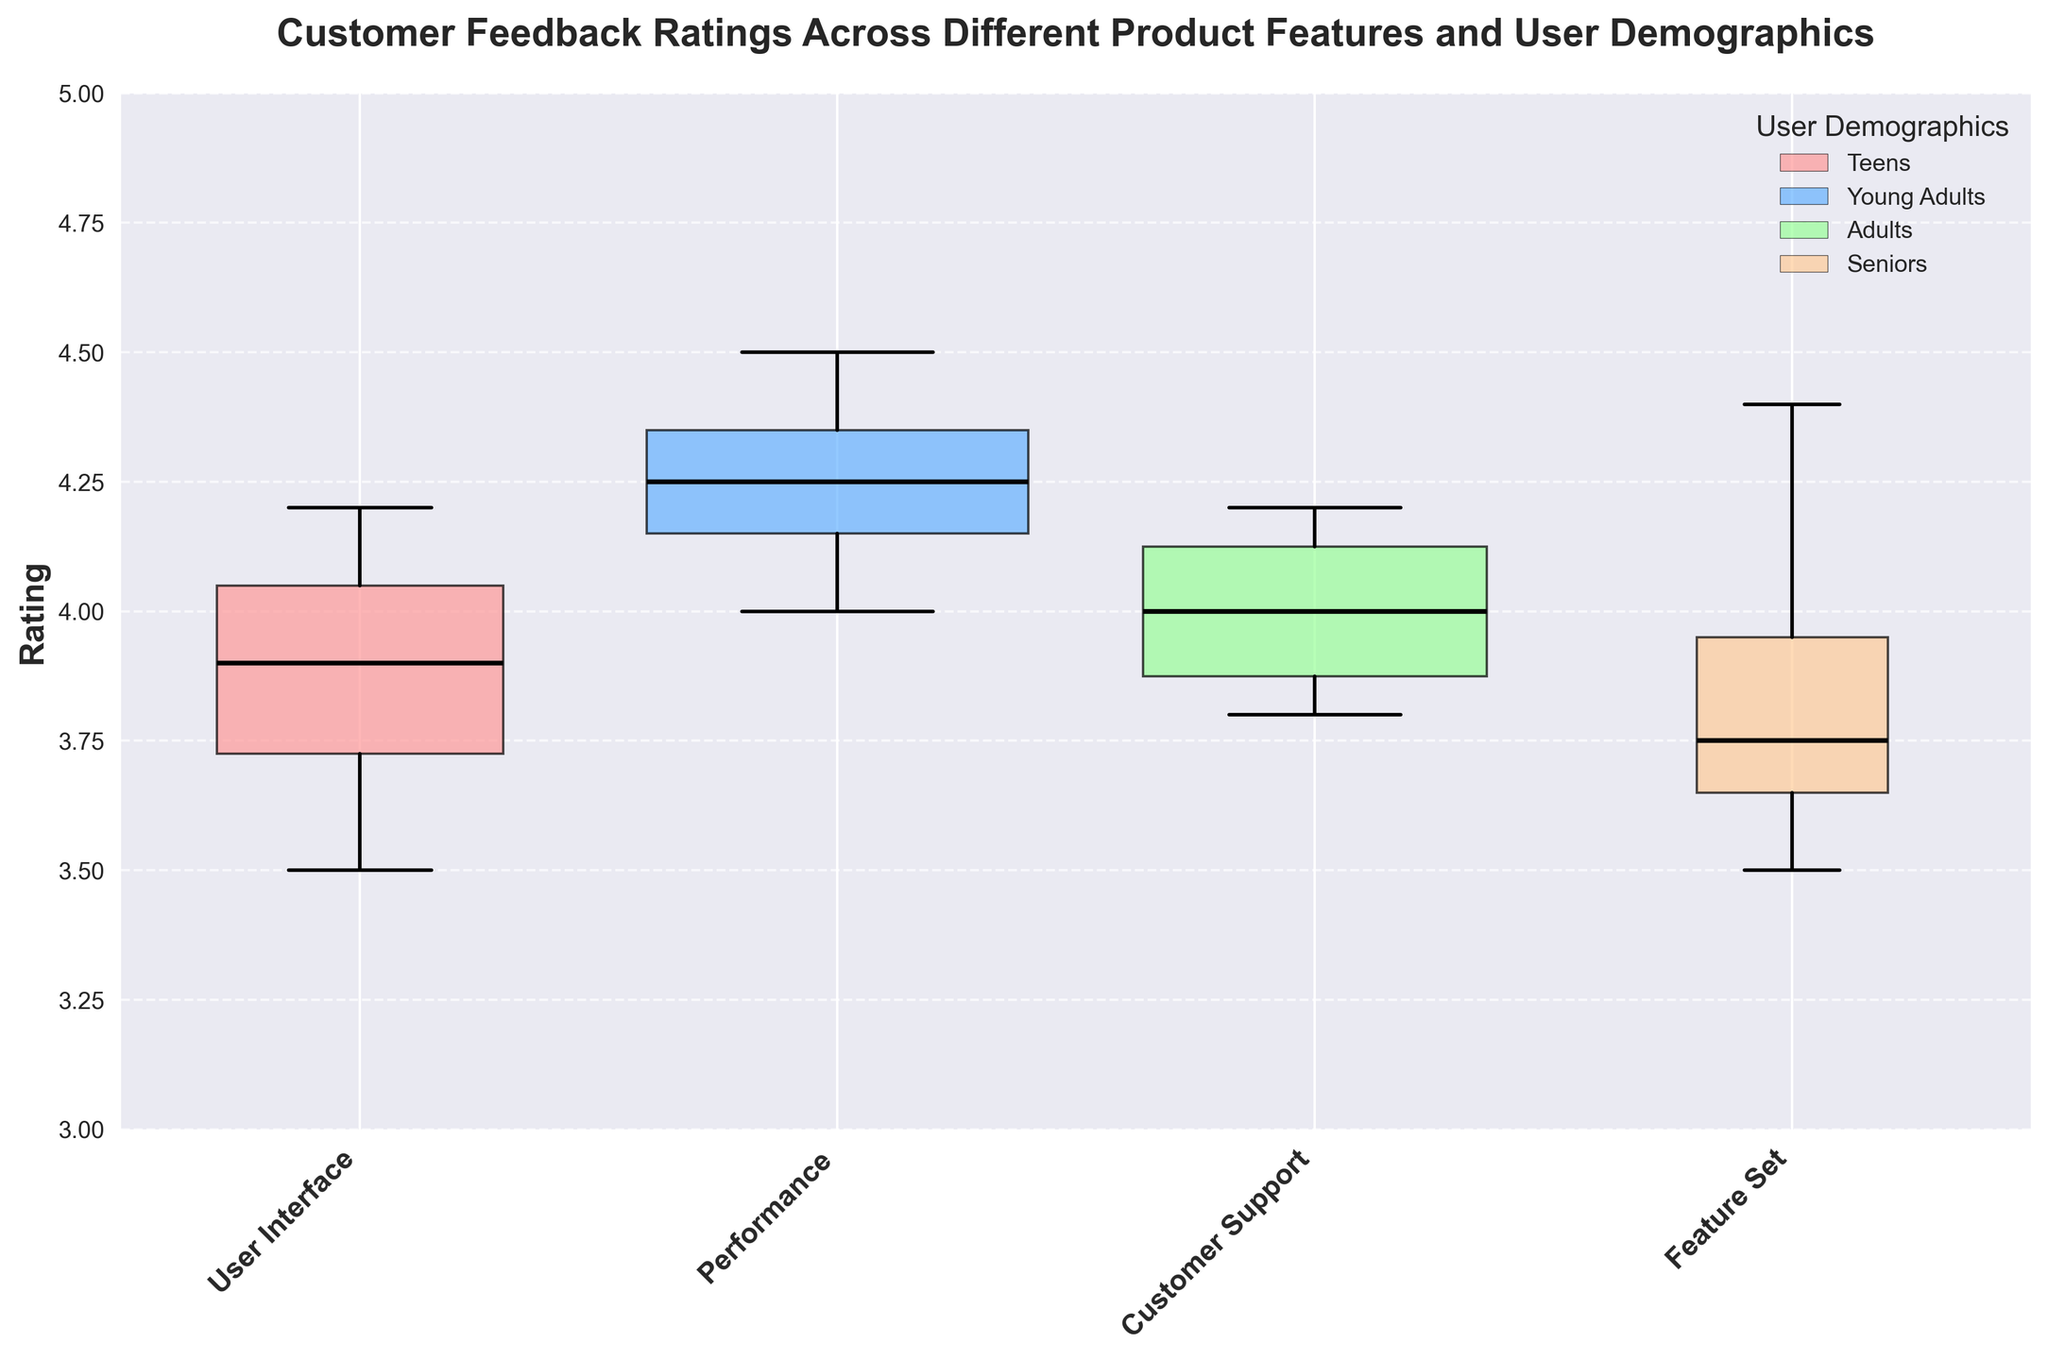what is the title of the plot? The title is shown at the top of the plot.
Answer: Customer Feedback Ratings Across Different Product Features and User Demographics which demographic group has the widest box plot? The width of the box plot indicates the count of ratings. The widest box plot belongs to the group with the highest count.
Answer: Young Adults which feature has the highest median rating among all demographics? The median rating is indicated by the black line in the box plot. The highest is in the Young Adults group for User Interface.
Answer: User Interface how does the performance rating for seniors compare to teens? Compare the box plots for the Performance feature for both demographics. Seniors have a median near 3.5, while Teens have a median near 3.8.
Answer: lower which demographic gave the lowest rating for customer support? The lowest median line for the Customer Support feature indicates this.
Answer: Teens do adults rate user interface higher or lower than feature set? Compare the median lines for Users Interface and Feature Set for Adults.
Answer: higher what is the median rating for young adults in customer support? Identify the median black line in the Customer Support box for Young Adults.
Answer: 4.0 across all features, which demographic has the most consistent ratings? Consistent ratings usually show less variability in box plots. Compare the spread of the box plots across demographics.
Answer: Young Adults how does the overall rating for teens compare to adults? Compare the overall spread and medians of the box plots for all features between Teens and Adults.
Answer: Teens tend lower which feature shows the most variation in ratings among seniors? Variation is indicated by the size of the box and whiskers. The larger the spread, the more the variation.
Answer: Customer Support 